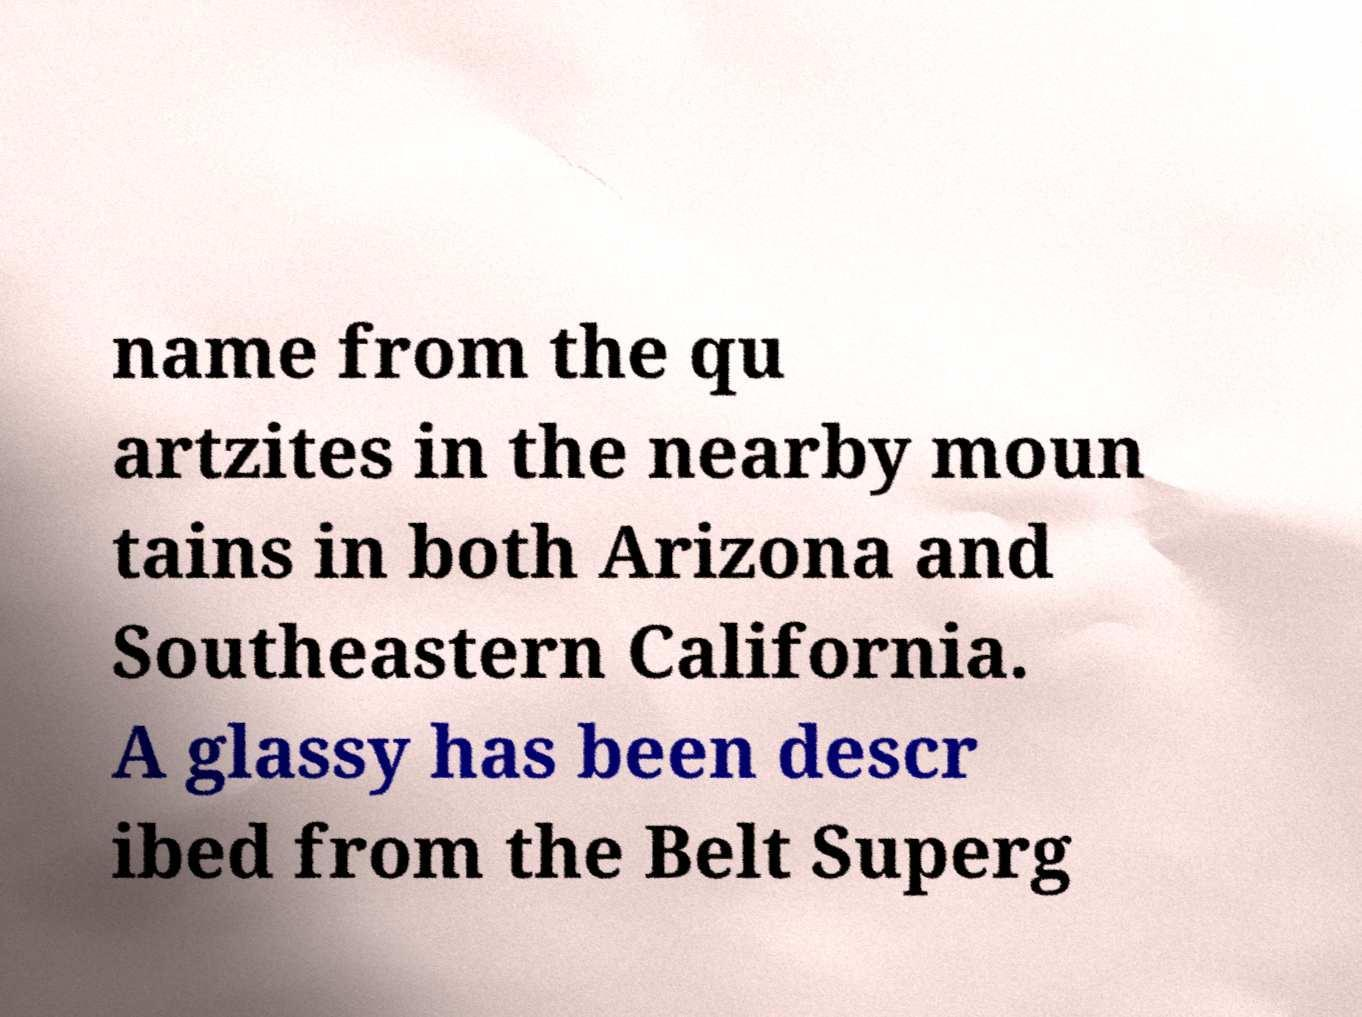There's text embedded in this image that I need extracted. Can you transcribe it verbatim? name from the qu artzites in the nearby moun tains in both Arizona and Southeastern California. A glassy has been descr ibed from the Belt Superg 